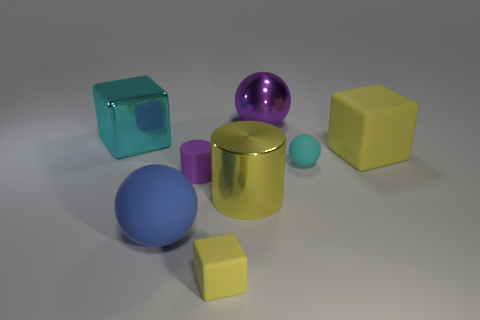Add 1 big shiny cylinders. How many objects exist? 9 Subtract all spheres. How many objects are left? 5 Subtract 1 cyan cubes. How many objects are left? 7 Subtract all blue objects. Subtract all yellow shiny objects. How many objects are left? 6 Add 1 small purple rubber things. How many small purple rubber things are left? 2 Add 3 large blue rubber objects. How many large blue rubber objects exist? 4 